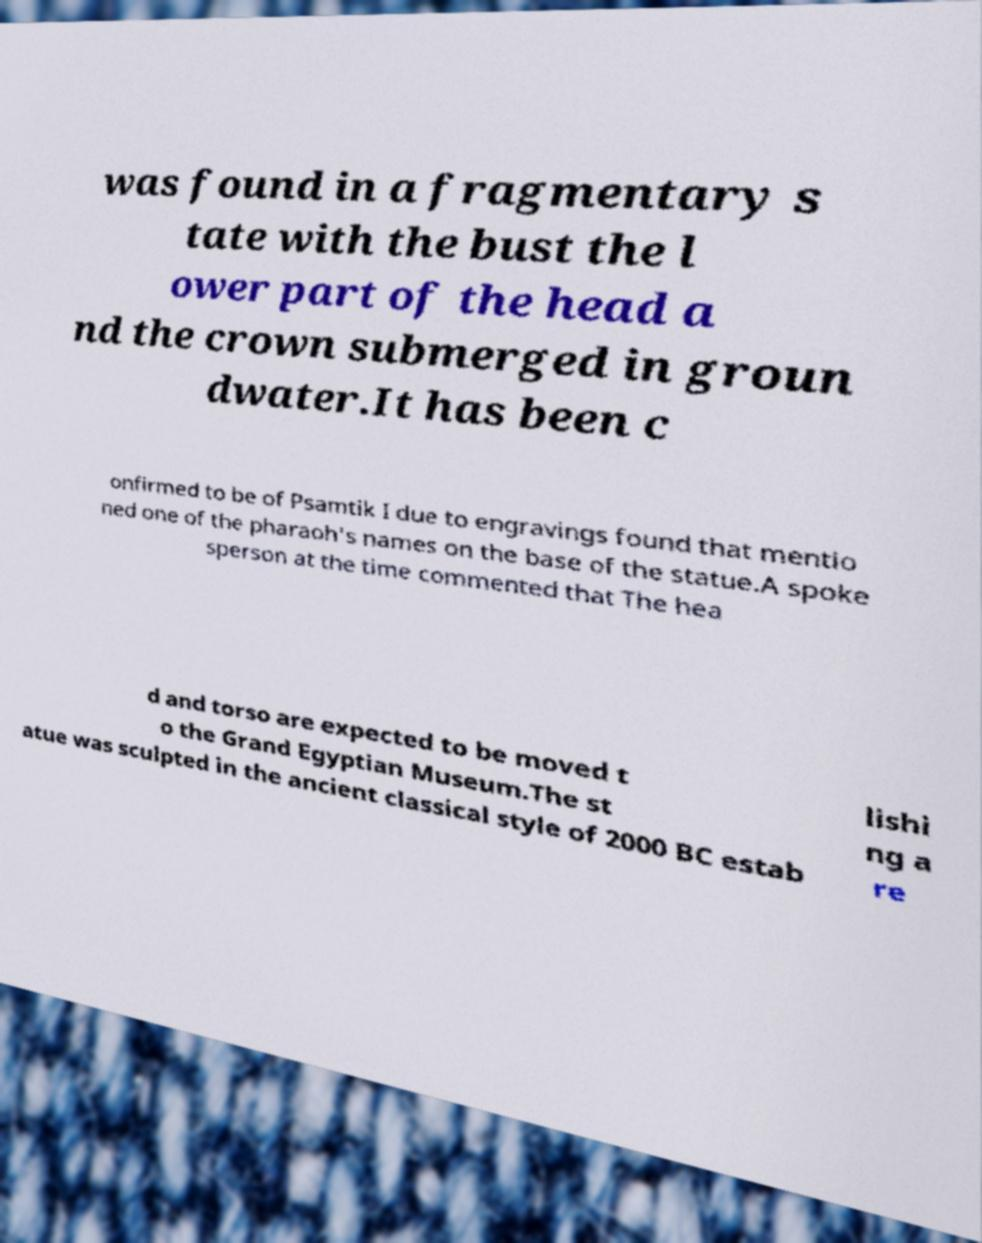Please read and relay the text visible in this image. What does it say? was found in a fragmentary s tate with the bust the l ower part of the head a nd the crown submerged in groun dwater.It has been c onfirmed to be of Psamtik I due to engravings found that mentio ned one of the pharaoh's names on the base of the statue.A spoke sperson at the time commented that The hea d and torso are expected to be moved t o the Grand Egyptian Museum.The st atue was sculpted in the ancient classical style of 2000 BC estab lishi ng a re 